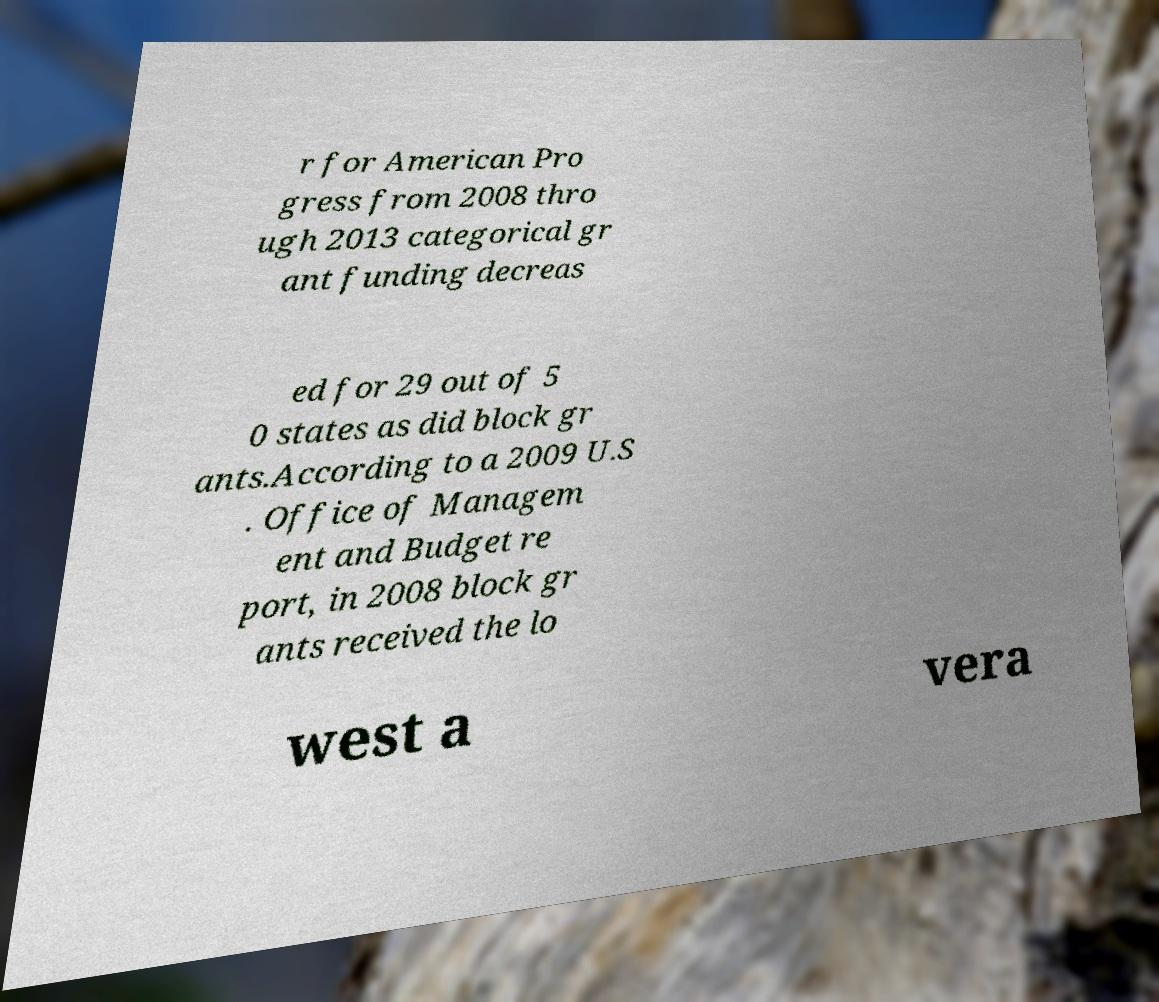I need the written content from this picture converted into text. Can you do that? r for American Pro gress from 2008 thro ugh 2013 categorical gr ant funding decreas ed for 29 out of 5 0 states as did block gr ants.According to a 2009 U.S . Office of Managem ent and Budget re port, in 2008 block gr ants received the lo west a vera 